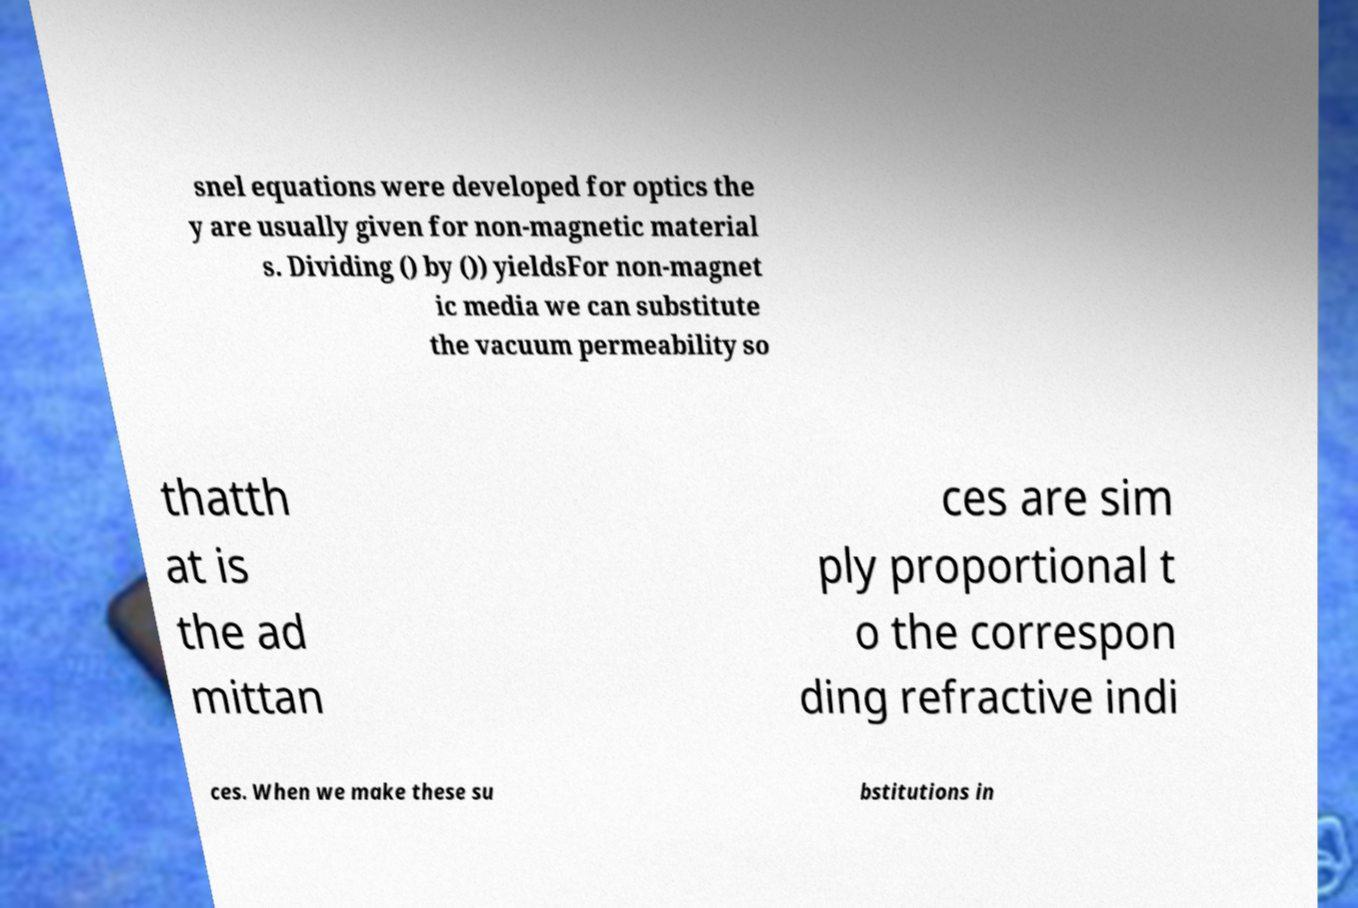Please read and relay the text visible in this image. What does it say? snel equations were developed for optics the y are usually given for non-magnetic material s. Dividing () by ()) yieldsFor non-magnet ic media we can substitute the vacuum permeability so thatth at is the ad mittan ces are sim ply proportional t o the correspon ding refractive indi ces. When we make these su bstitutions in 